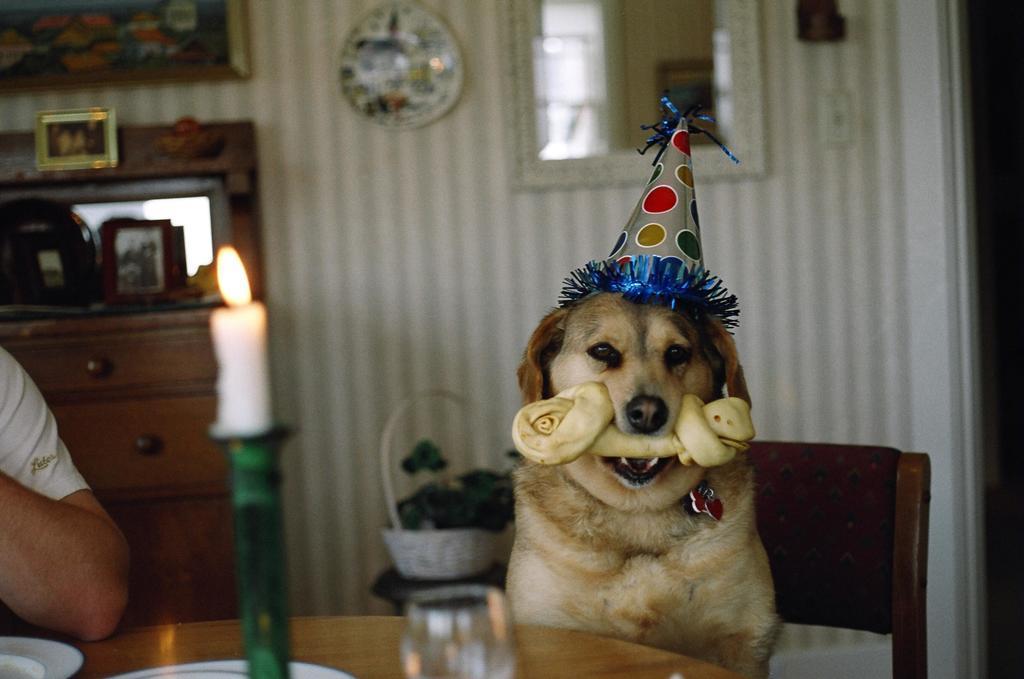Describe this image in one or two sentences. In this image I can see a candle. On the right side of this image there is a dog sitting on the table, there is some food item in its mouth and one cap on its head. On the left side of this image I can see a person's hand and he is wearing a white shirt. At the back of this person I can see a table and there are some frames and photos on it. And in the background I can see a wall and there is a mirror. And in the bottom of this image I can see a small stool and basket on it. And here I can see a dining table and glass and some plates on it. 